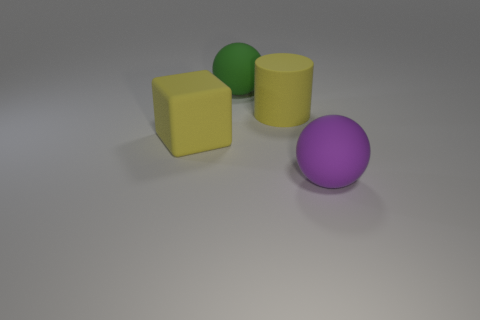Add 2 matte spheres. How many objects exist? 6 Subtract all cylinders. How many objects are left? 3 Subtract all yellow objects. Subtract all tiny yellow cubes. How many objects are left? 2 Add 2 green things. How many green things are left? 3 Add 1 big yellow matte cylinders. How many big yellow matte cylinders exist? 2 Subtract 0 red cubes. How many objects are left? 4 